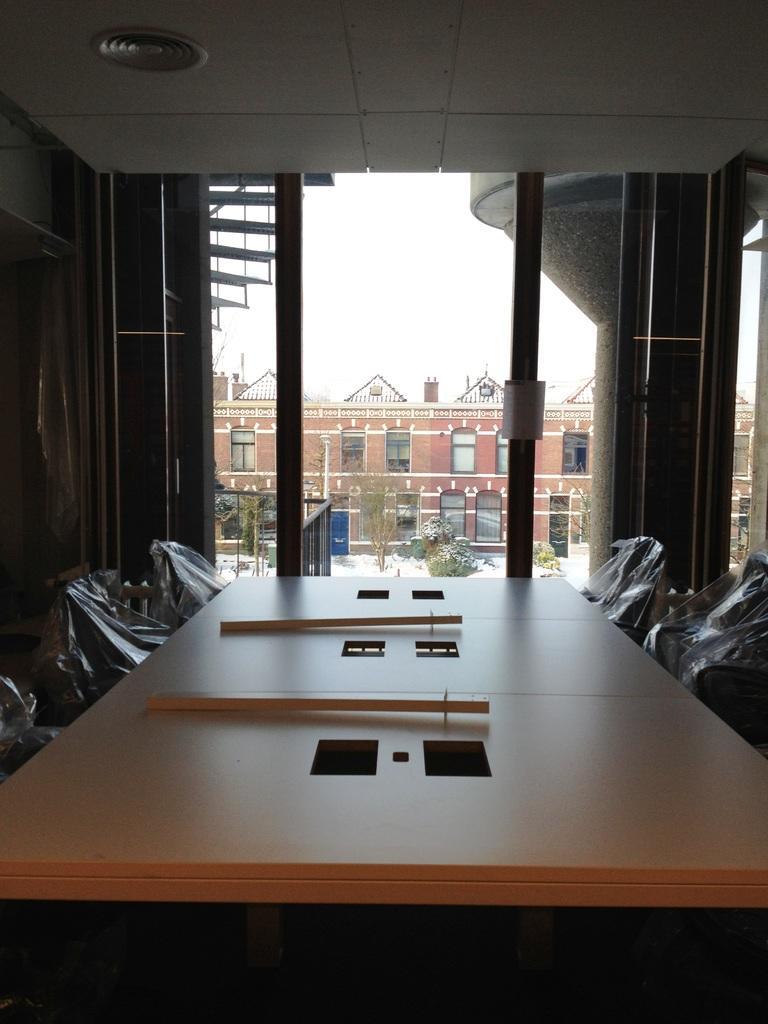Can you describe this image briefly? The picture is taken in a room. In the foreground of the picture there are chairs, table, on the table there are some objects. In the center of the picture there are staircase, pillar and glass windows, outside the windows there raining, trees, road and buildings. In the background it is sky. 